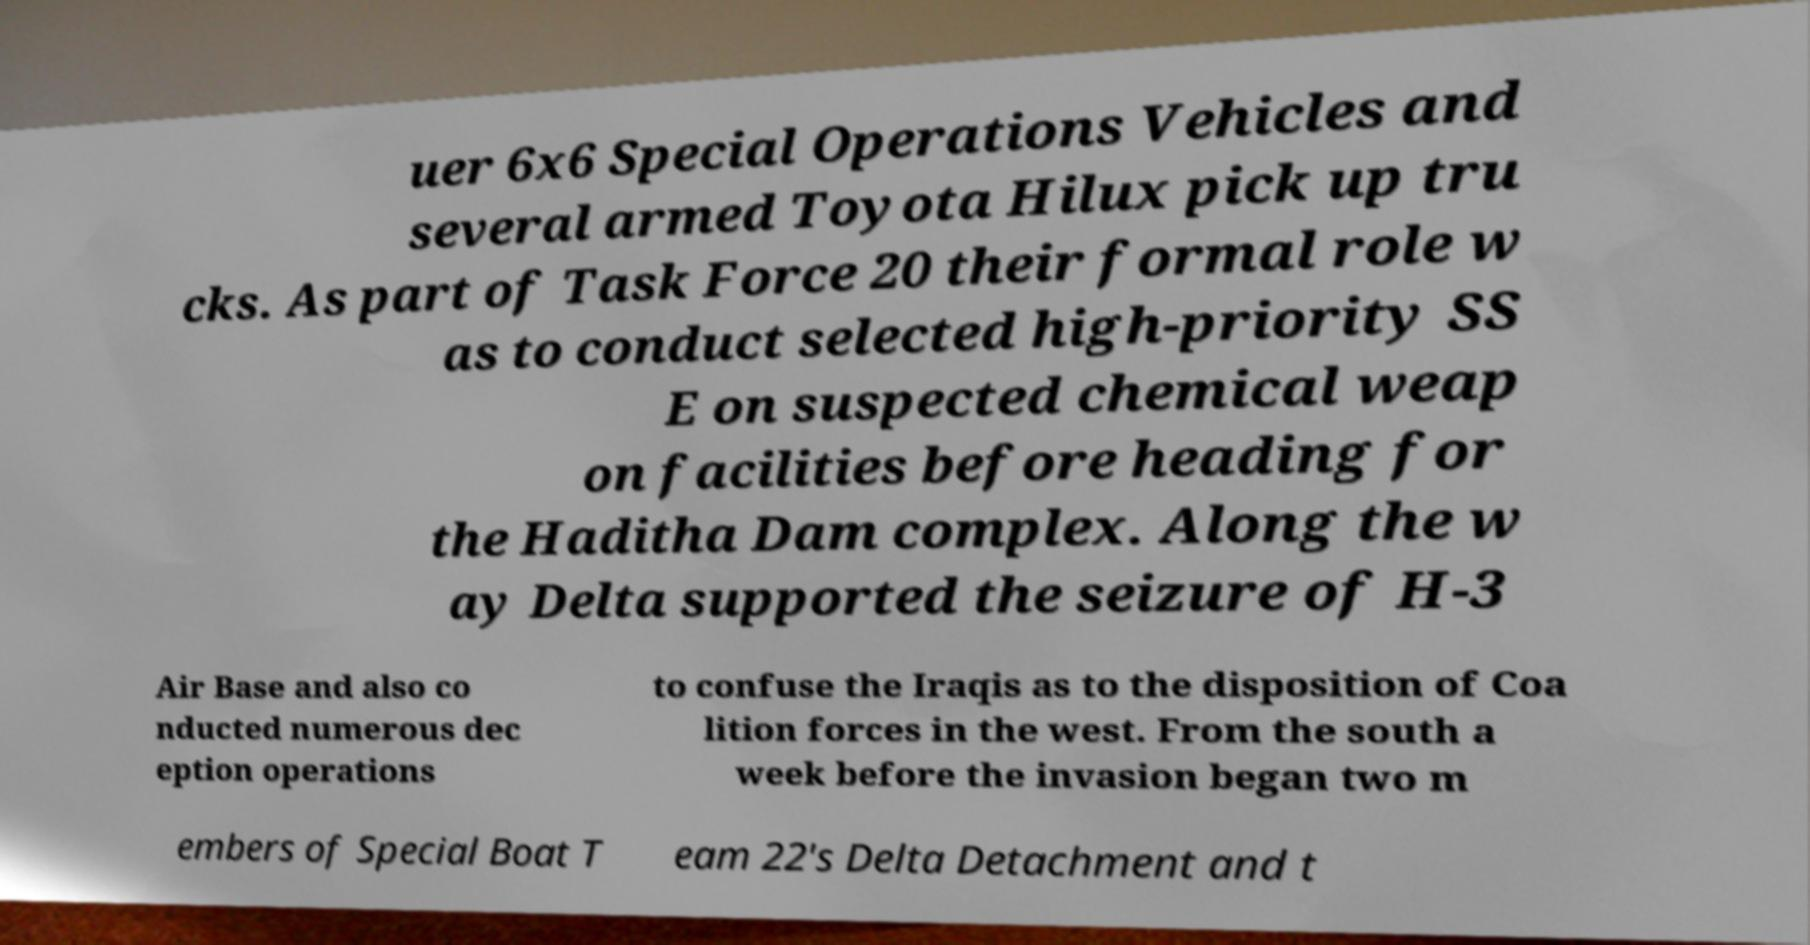Could you assist in decoding the text presented in this image and type it out clearly? uer 6x6 Special Operations Vehicles and several armed Toyota Hilux pick up tru cks. As part of Task Force 20 their formal role w as to conduct selected high-priority SS E on suspected chemical weap on facilities before heading for the Haditha Dam complex. Along the w ay Delta supported the seizure of H-3 Air Base and also co nducted numerous dec eption operations to confuse the Iraqis as to the disposition of Coa lition forces in the west. From the south a week before the invasion began two m embers of Special Boat T eam 22's Delta Detachment and t 